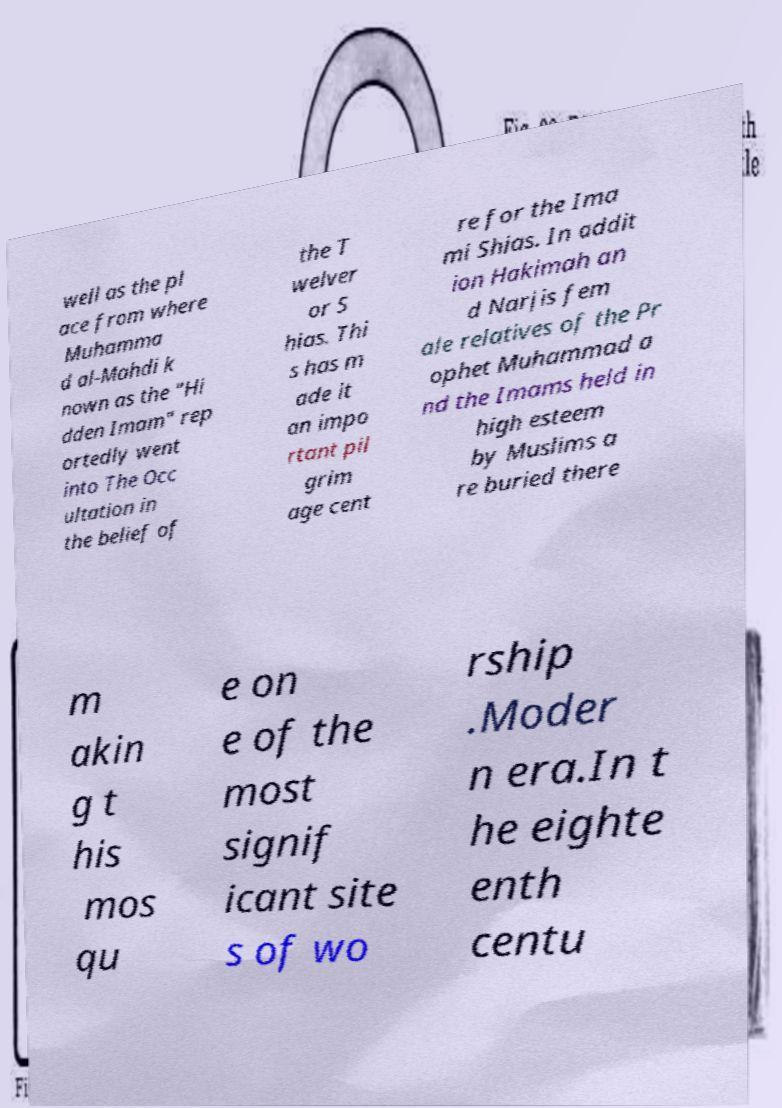Please read and relay the text visible in this image. What does it say? well as the pl ace from where Muhamma d al-Mahdi k nown as the "Hi dden Imam" rep ortedly went into The Occ ultation in the belief of the T welver or S hias. Thi s has m ade it an impo rtant pil grim age cent re for the Ima mi Shias. In addit ion Hakimah an d Narjis fem ale relatives of the Pr ophet Muhammad a nd the Imams held in high esteem by Muslims a re buried there m akin g t his mos qu e on e of the most signif icant site s of wo rship .Moder n era.In t he eighte enth centu 